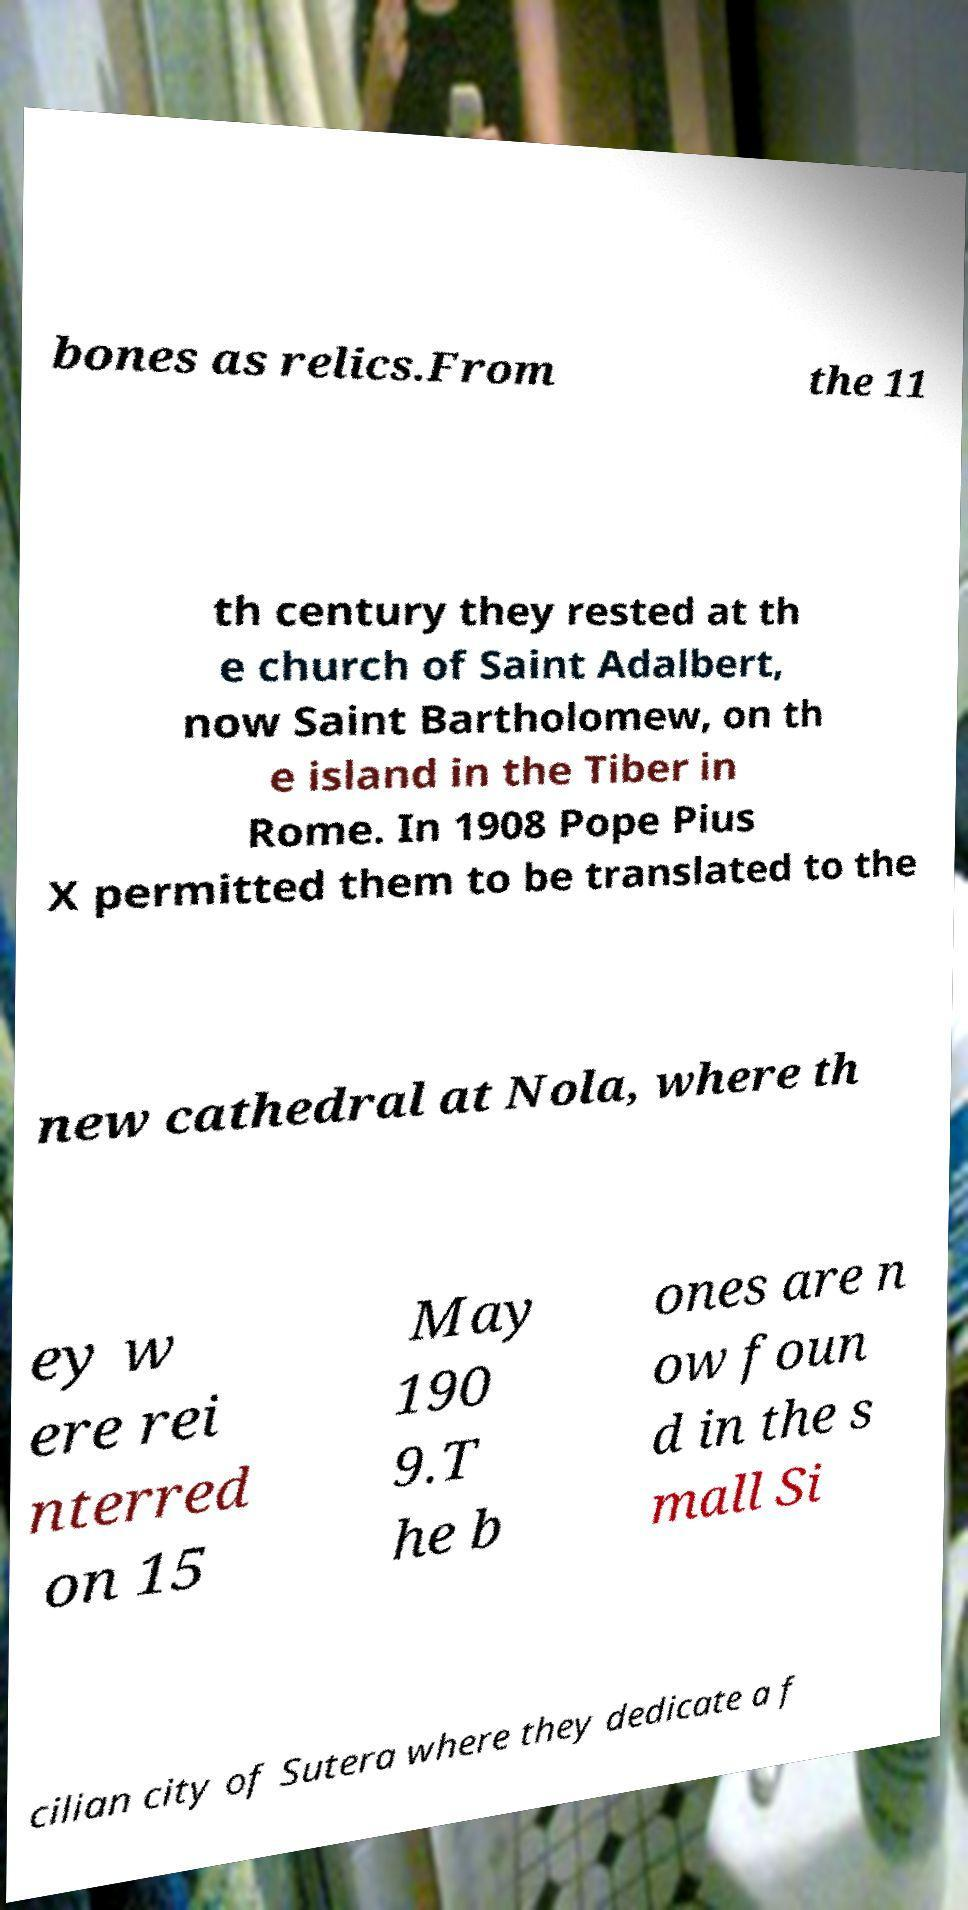I need the written content from this picture converted into text. Can you do that? bones as relics.From the 11 th century they rested at th e church of Saint Adalbert, now Saint Bartholomew, on th e island in the Tiber in Rome. In 1908 Pope Pius X permitted them to be translated to the new cathedral at Nola, where th ey w ere rei nterred on 15 May 190 9.T he b ones are n ow foun d in the s mall Si cilian city of Sutera where they dedicate a f 